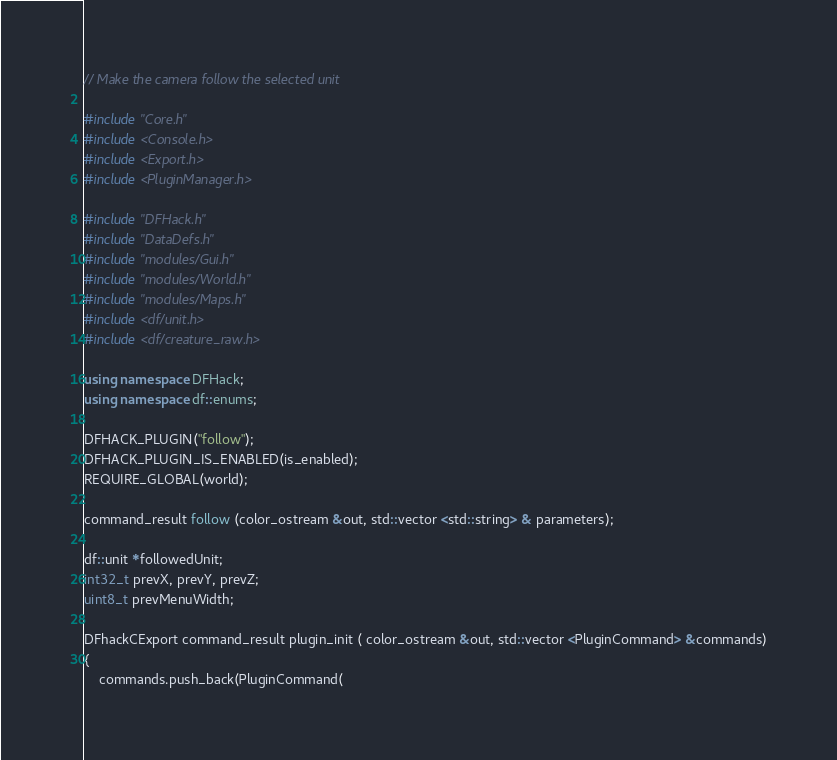<code> <loc_0><loc_0><loc_500><loc_500><_C++_>// Make the camera follow the selected unit

#include "Core.h"
#include <Console.h>
#include <Export.h>
#include <PluginManager.h>

#include "DFHack.h"
#include "DataDefs.h"
#include "modules/Gui.h"
#include "modules/World.h"
#include "modules/Maps.h"
#include <df/unit.h>
#include <df/creature_raw.h>

using namespace DFHack;
using namespace df::enums;

DFHACK_PLUGIN("follow");
DFHACK_PLUGIN_IS_ENABLED(is_enabled);
REQUIRE_GLOBAL(world);

command_result follow (color_ostream &out, std::vector <std::string> & parameters);

df::unit *followedUnit;
int32_t prevX, prevY, prevZ;
uint8_t prevMenuWidth;

DFhackCExport command_result plugin_init ( color_ostream &out, std::vector <PluginCommand> &commands)
{
    commands.push_back(PluginCommand(</code> 